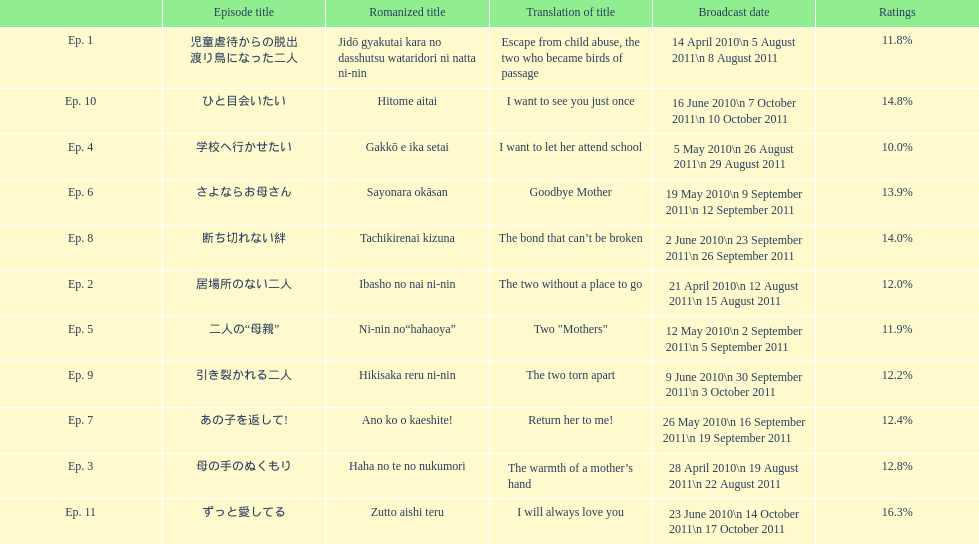Other than the 10th episode, which other episode has a 14% rating? Ep. 8. 